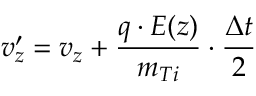<formula> <loc_0><loc_0><loc_500><loc_500>v _ { z } ^ { \prime } = v _ { z } + \frac { q \cdot E ( z ) } { m _ { T i } } \cdot \frac { \Delta t } { 2 }</formula> 